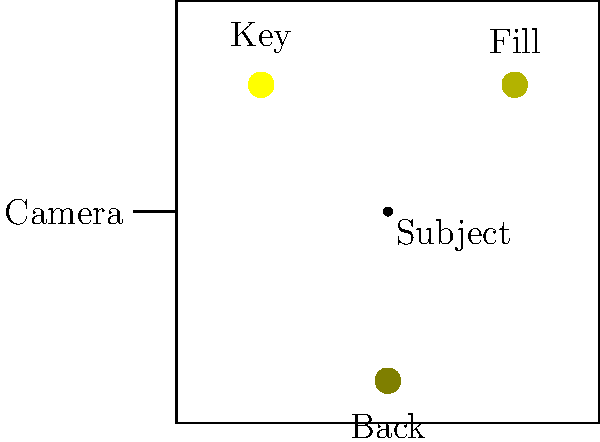In this studio lighting setup, which light source is typically the brightest and serves as the main illumination for the subject? To determine the brightest light source in a typical three-point lighting setup:

1. Identify the three lights:
   - Key light: Located at (2,8)
   - Fill light: Located at (8,8)
   - Backlight: Located at (5,1)

2. Understand the purpose of each light:
   - Key light: Main illumination, creates primary shadows
   - Fill light: Softens shadows created by the key light
   - Backlight: Separates subject from background, adds depth

3. Compare light intensities:
   - Key light is typically the brightest
   - Fill light is usually 1/2 to 1/4 the intensity of the key light
   - Backlight is often similar in intensity to the fill light or slightly brighter

4. Consider positioning:
   - Key light is closest to the subject and at a 45-degree angle
   - This position maximizes its impact on the subject's appearance

5. Conclude:
   The key light, positioned at (2,8), is the brightest and serves as the main illumination for the subject.
Answer: Key light 